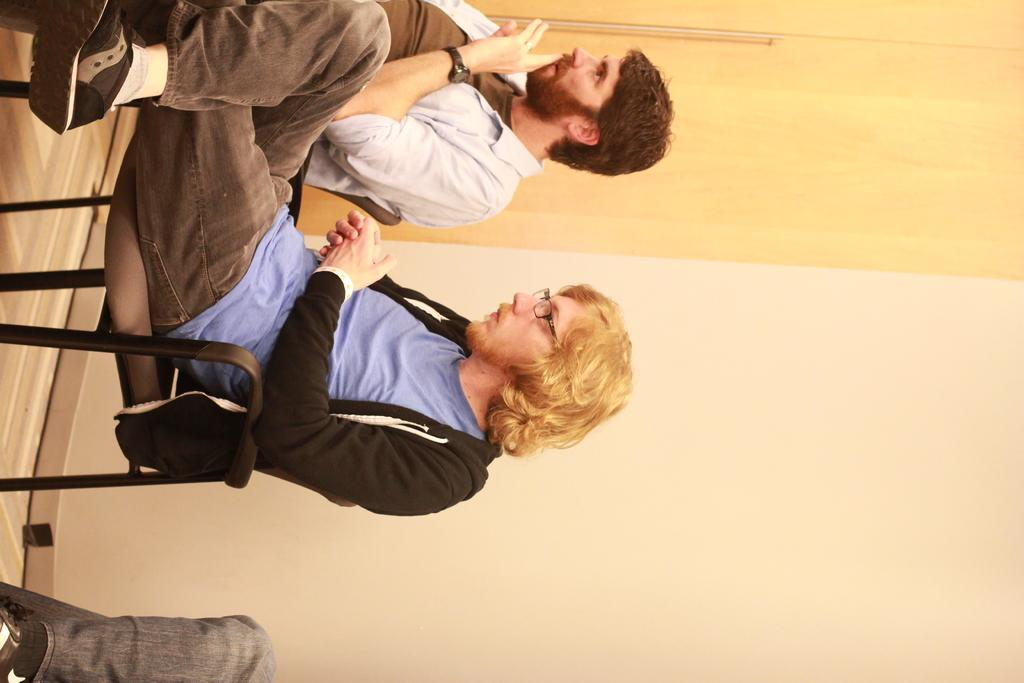What are the people in the image doing? The people in the image are sitting on chairs. Can you describe the man in the image? The man in the image is wearing spectacles and a jacket. What color is the wall in the image? The wall in the image is cream-colored. Where can the stamp be found in the image? There is no stamp present in the image. What type of clover is growing on the man's jacket in the image? There is no clover present on the man's jacket or in the image. 